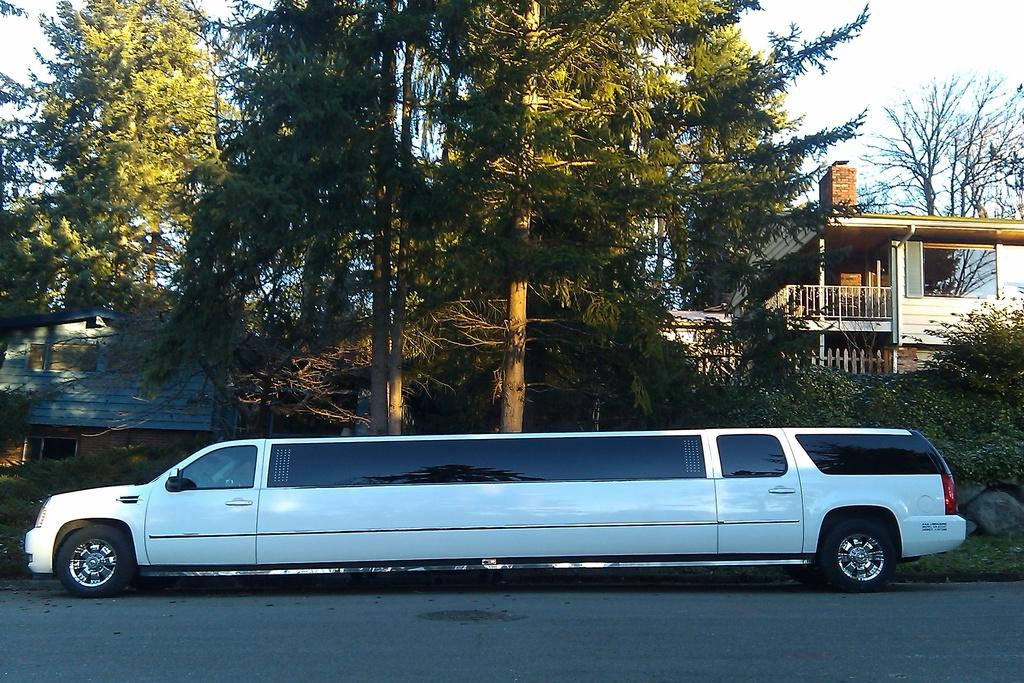What type of vehicle is in the image? There is a white vehicle in the image. Where is the vehicle located? The vehicle is on the road. What can be seen in the background of the image? There are buildings and trees in the background of the image. What type of creature is sitting in the driver's seat of the vehicle? There is no creature visible in the image, and it is not possible to determine who or what is driving the vehicle. 